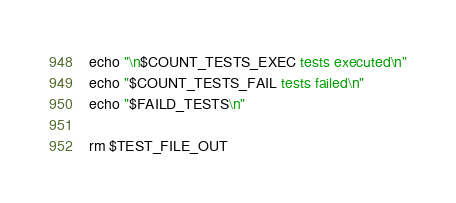<code> <loc_0><loc_0><loc_500><loc_500><_Bash_>echo "\n$COUNT_TESTS_EXEC tests executed\n"
echo "$COUNT_TESTS_FAIL tests failed\n"
echo "$FAILD_TESTS\n"

rm $TEST_FILE_OUT 



</code> 